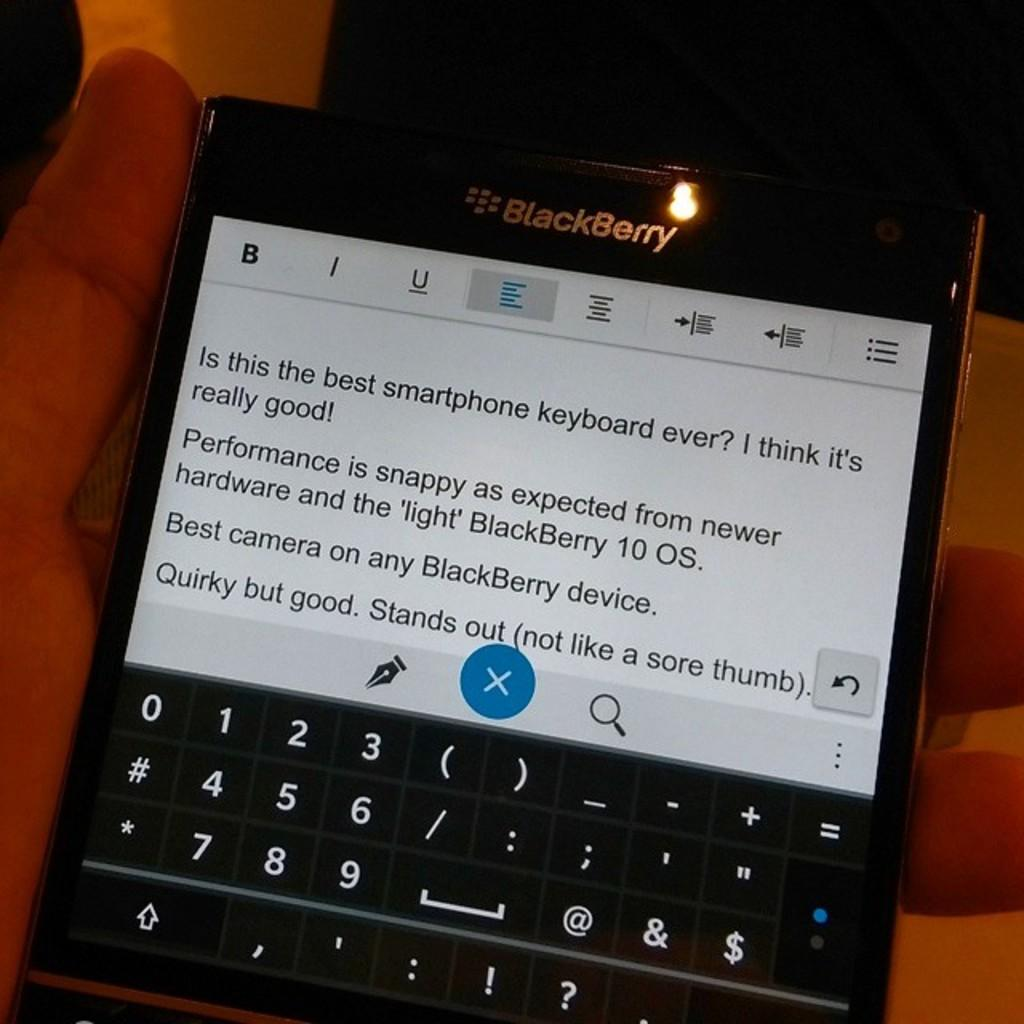<image>
Present a compact description of the photo's key features. hand holding black blackberry with a message on screen asking "is this the best smartphone keyboard ever?" 